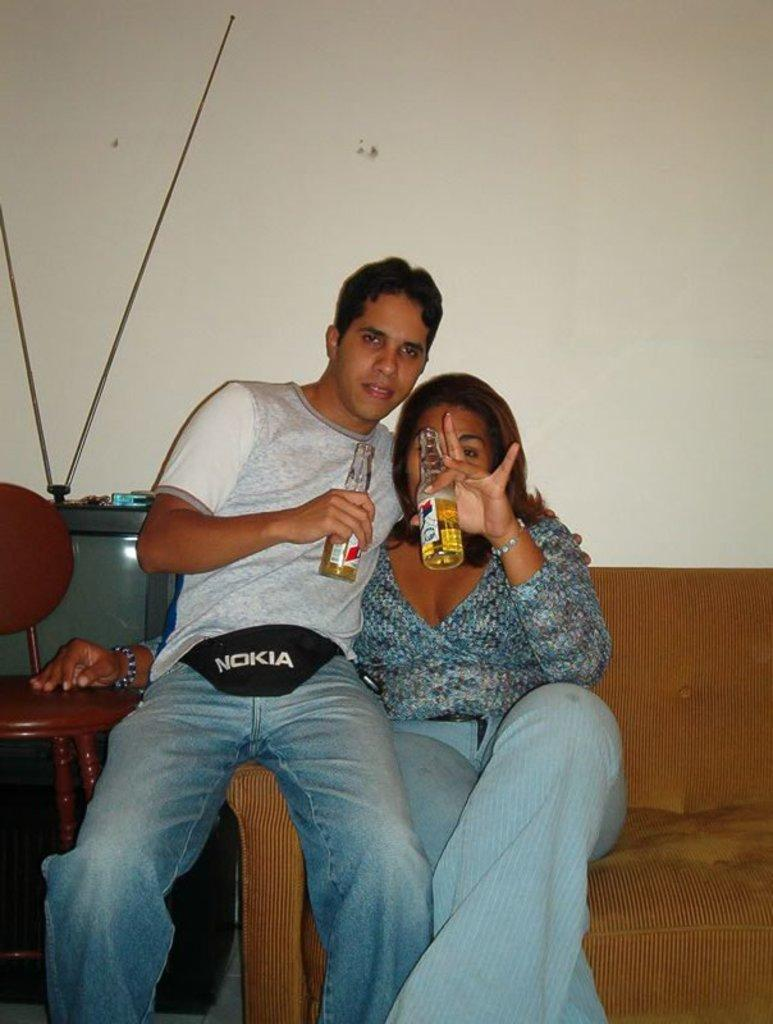How many people are in the image? There is a man and a woman in the image. What are the man and woman holding in the image? The man and woman are holding a bottle. What type of furniture is present in the image? There is a sofa, a television, and a sitting chair in the image. What is the purpose of the horses in the image? There are no horses present in the image. Is there a hose visible in the image? There is no hose visible in the image. 